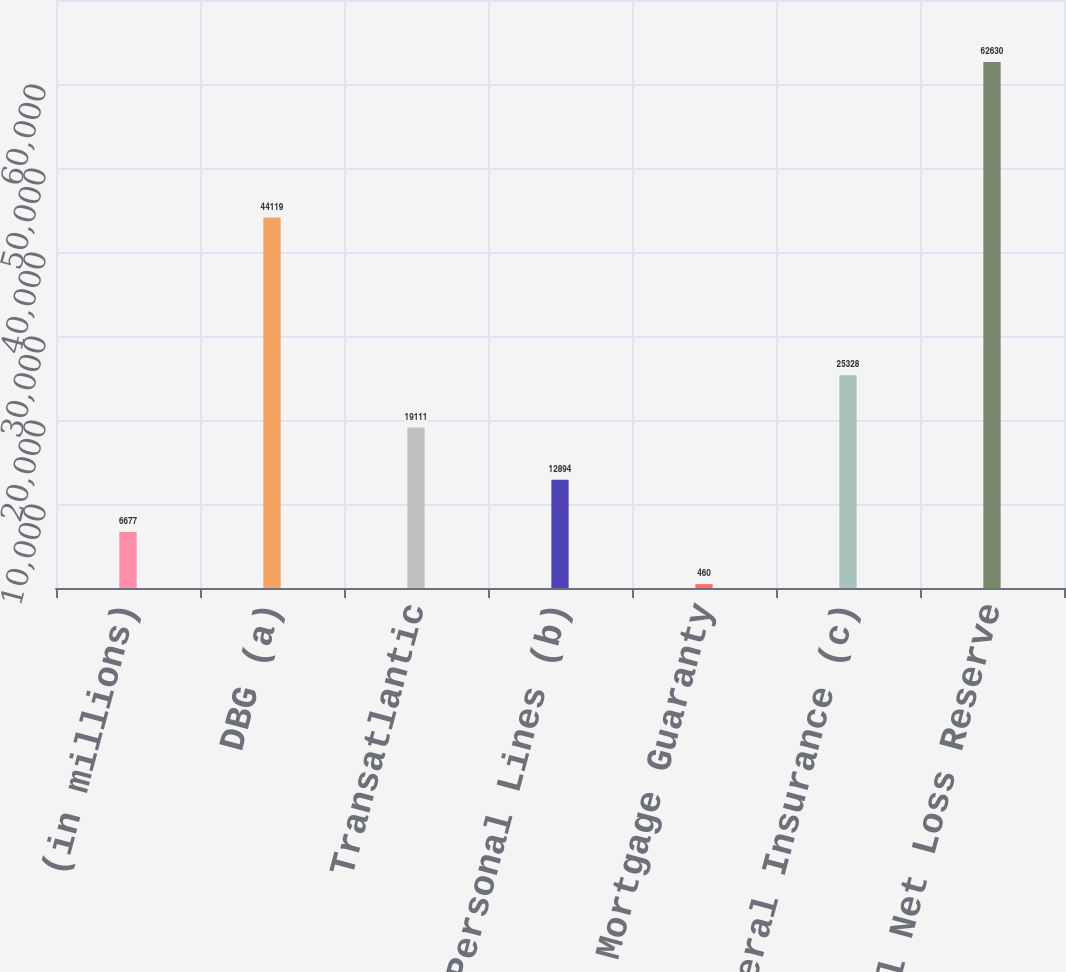<chart> <loc_0><loc_0><loc_500><loc_500><bar_chart><fcel>(in millions)<fcel>DBG (a)<fcel>Transatlantic<fcel>Personal Lines (b)<fcel>Mortgage Guaranty<fcel>Foreign General Insurance (c)<fcel>Total Net Loss Reserve<nl><fcel>6677<fcel>44119<fcel>19111<fcel>12894<fcel>460<fcel>25328<fcel>62630<nl></chart> 